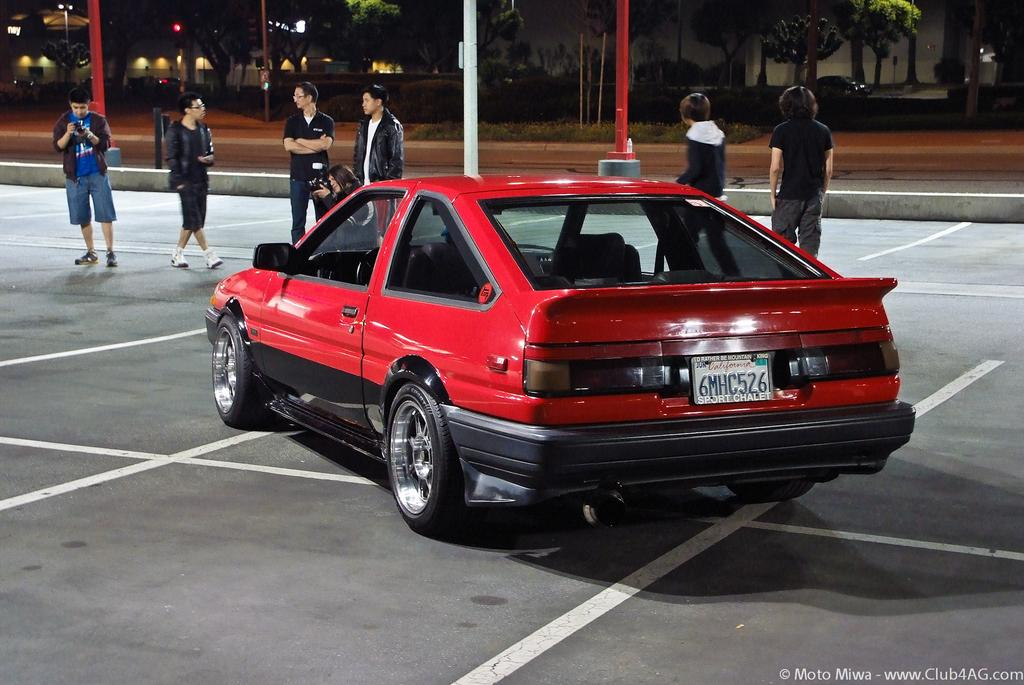What color is the car in the image? The car in the image is red. What else can be seen in the image besides the car? There are people standing, poles, buildings, trees, and another car visible in the image. Can you describe the people in the image? The facts provided do not give specific details about the people in the image. What type of structures are present in the image? There are buildings in the image. What type of vegetation is present in the image? There are trees in the image. How does the car's wealth compare to the tub's wealth in the image? There is no tub present in the image, so it is not possible to compare the car's wealth to the tub's wealth. 